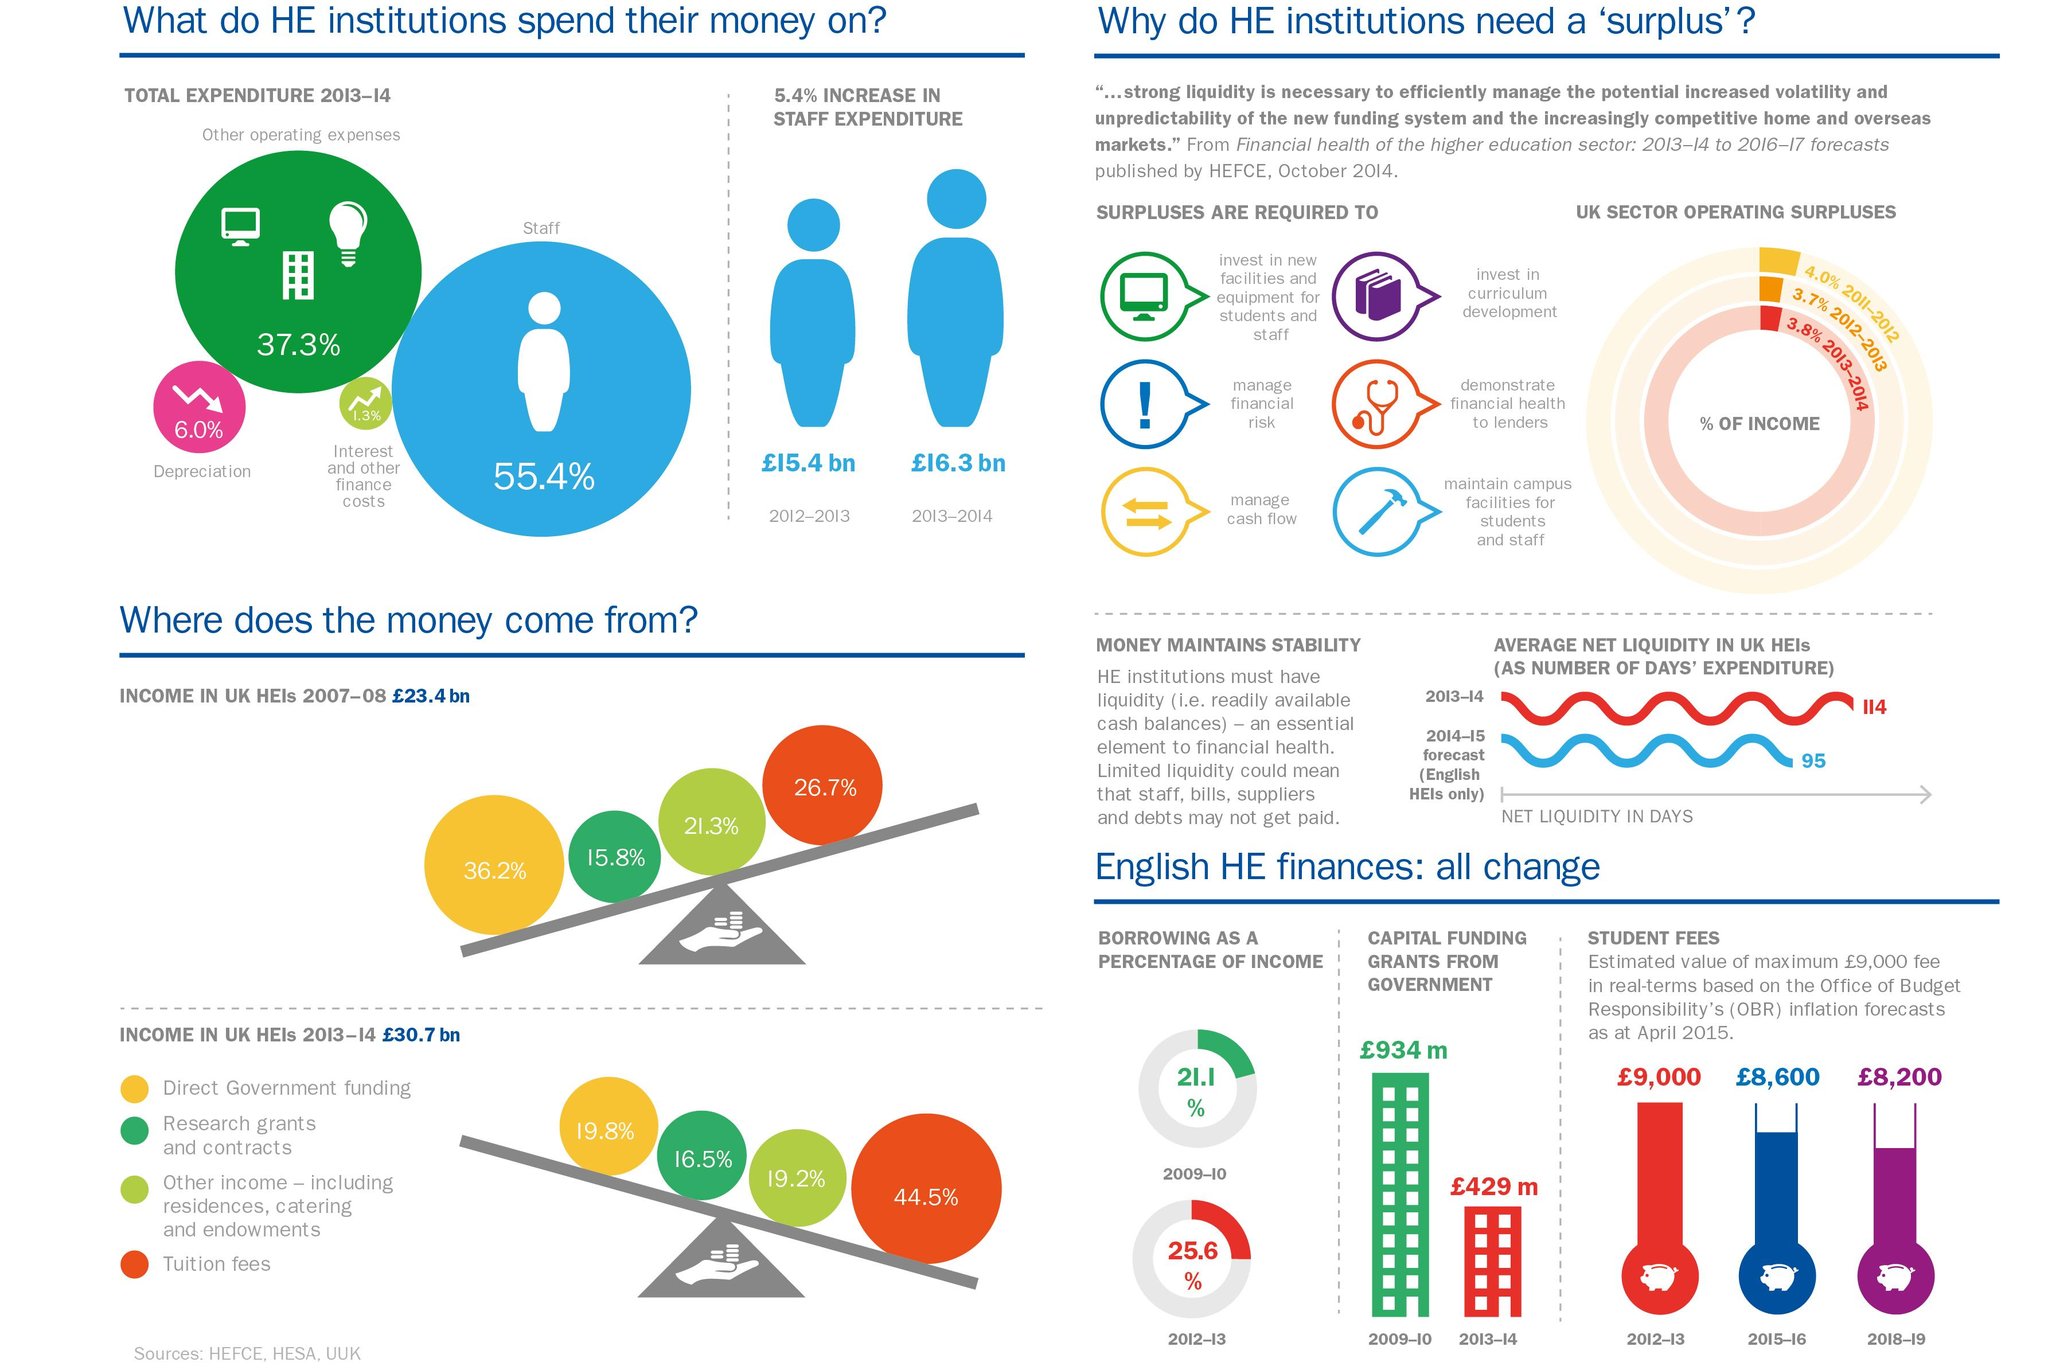Indicate a few pertinent items in this graphic. The color used to represent income from student fees for the academic year 2012-13 is red. In total, 6.0% of the expenditure was allocated to depreciation. The wording "What is the image used for surpluses required for the maintenance of campus facilities - books, stethoscope or hammer ? Hammer.." is a question that requires a specific answer. The correct answer to the question is "hammer. According to data from 2007-8, the largest source of income for higher education institutions (HEIs) in the UK was direct government funding. The amount of expenditure incurred on staff in the year 2012-13 was £15.4 billion. 